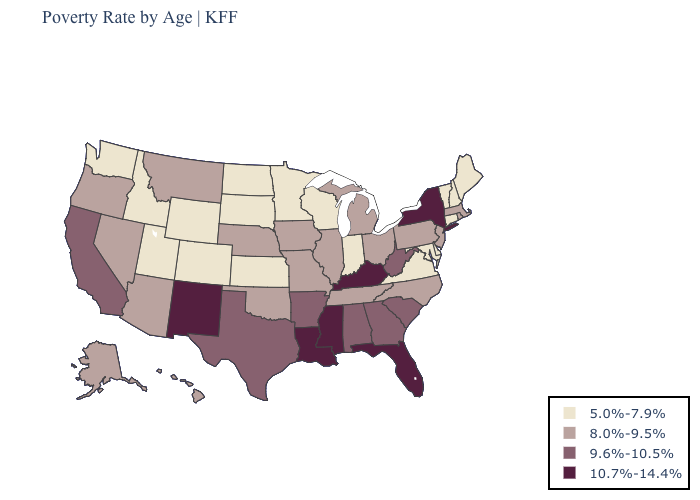Name the states that have a value in the range 9.6%-10.5%?
Answer briefly. Alabama, Arkansas, California, Georgia, South Carolina, Texas, West Virginia. What is the value of Tennessee?
Short answer required. 8.0%-9.5%. Name the states that have a value in the range 9.6%-10.5%?
Write a very short answer. Alabama, Arkansas, California, Georgia, South Carolina, Texas, West Virginia. What is the value of Rhode Island?
Short answer required. 8.0%-9.5%. What is the lowest value in the USA?
Be succinct. 5.0%-7.9%. What is the highest value in the USA?
Quick response, please. 10.7%-14.4%. What is the value of Idaho?
Keep it brief. 5.0%-7.9%. What is the value of Maryland?
Answer briefly. 5.0%-7.9%. Does Alaska have the highest value in the USA?
Quick response, please. No. Name the states that have a value in the range 10.7%-14.4%?
Keep it brief. Florida, Kentucky, Louisiana, Mississippi, New Mexico, New York. What is the highest value in the USA?
Short answer required. 10.7%-14.4%. Does New York have the highest value in the Northeast?
Quick response, please. Yes. Is the legend a continuous bar?
Concise answer only. No. Does Mississippi have a lower value than Delaware?
Answer briefly. No. Does North Carolina have a lower value than Oregon?
Write a very short answer. No. 